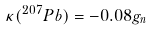<formula> <loc_0><loc_0><loc_500><loc_500>\kappa ( ^ { 2 0 7 } P b ) = - 0 . 0 8 g _ { n }</formula> 